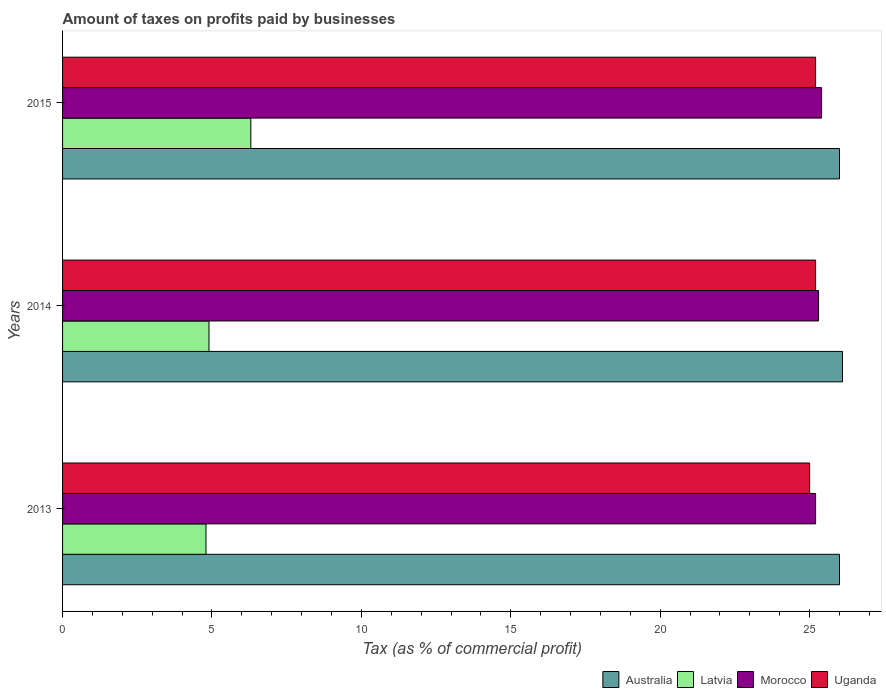How many different coloured bars are there?
Provide a succinct answer. 4. How many groups of bars are there?
Make the answer very short. 3. Are the number of bars per tick equal to the number of legend labels?
Your response must be concise. Yes. Are the number of bars on each tick of the Y-axis equal?
Offer a very short reply. Yes. How many bars are there on the 1st tick from the top?
Make the answer very short. 4. What is the label of the 1st group of bars from the top?
Make the answer very short. 2015. In how many cases, is the number of bars for a given year not equal to the number of legend labels?
Provide a succinct answer. 0. What is the percentage of taxes paid by businesses in Morocco in 2014?
Ensure brevity in your answer.  25.3. Across all years, what is the maximum percentage of taxes paid by businesses in Uganda?
Keep it short and to the point. 25.2. Across all years, what is the minimum percentage of taxes paid by businesses in Latvia?
Provide a short and direct response. 4.8. In which year was the percentage of taxes paid by businesses in Morocco maximum?
Offer a terse response. 2015. In which year was the percentage of taxes paid by businesses in Uganda minimum?
Keep it short and to the point. 2013. What is the difference between the percentage of taxes paid by businesses in Morocco in 2013 and that in 2014?
Provide a short and direct response. -0.1. What is the difference between the percentage of taxes paid by businesses in Australia in 2014 and the percentage of taxes paid by businesses in Uganda in 2015?
Your answer should be very brief. 0.9. What is the average percentage of taxes paid by businesses in Latvia per year?
Make the answer very short. 5.33. In the year 2015, what is the difference between the percentage of taxes paid by businesses in Australia and percentage of taxes paid by businesses in Morocco?
Offer a very short reply. 0.6. What is the ratio of the percentage of taxes paid by businesses in Morocco in 2013 to that in 2014?
Make the answer very short. 1. Is the percentage of taxes paid by businesses in Australia in 2013 less than that in 2014?
Offer a terse response. Yes. What is the difference between the highest and the second highest percentage of taxes paid by businesses in Australia?
Offer a very short reply. 0.1. Is the sum of the percentage of taxes paid by businesses in Morocco in 2013 and 2015 greater than the maximum percentage of taxes paid by businesses in Latvia across all years?
Keep it short and to the point. Yes. What does the 3rd bar from the bottom in 2015 represents?
Offer a terse response. Morocco. How many bars are there?
Ensure brevity in your answer.  12. Are all the bars in the graph horizontal?
Offer a very short reply. Yes. How many years are there in the graph?
Give a very brief answer. 3. What is the difference between two consecutive major ticks on the X-axis?
Your answer should be very brief. 5. How many legend labels are there?
Make the answer very short. 4. What is the title of the graph?
Your answer should be very brief. Amount of taxes on profits paid by businesses. Does "Marshall Islands" appear as one of the legend labels in the graph?
Offer a terse response. No. What is the label or title of the X-axis?
Provide a succinct answer. Tax (as % of commercial profit). What is the Tax (as % of commercial profit) in Australia in 2013?
Provide a succinct answer. 26. What is the Tax (as % of commercial profit) in Latvia in 2013?
Your answer should be very brief. 4.8. What is the Tax (as % of commercial profit) in Morocco in 2013?
Provide a succinct answer. 25.2. What is the Tax (as % of commercial profit) in Australia in 2014?
Provide a succinct answer. 26.1. What is the Tax (as % of commercial profit) in Latvia in 2014?
Your answer should be compact. 4.9. What is the Tax (as % of commercial profit) in Morocco in 2014?
Make the answer very short. 25.3. What is the Tax (as % of commercial profit) in Uganda in 2014?
Give a very brief answer. 25.2. What is the Tax (as % of commercial profit) in Australia in 2015?
Make the answer very short. 26. What is the Tax (as % of commercial profit) in Morocco in 2015?
Ensure brevity in your answer.  25.4. What is the Tax (as % of commercial profit) of Uganda in 2015?
Give a very brief answer. 25.2. Across all years, what is the maximum Tax (as % of commercial profit) in Australia?
Offer a terse response. 26.1. Across all years, what is the maximum Tax (as % of commercial profit) in Morocco?
Your answer should be compact. 25.4. Across all years, what is the maximum Tax (as % of commercial profit) in Uganda?
Provide a succinct answer. 25.2. Across all years, what is the minimum Tax (as % of commercial profit) of Morocco?
Keep it short and to the point. 25.2. Across all years, what is the minimum Tax (as % of commercial profit) in Uganda?
Provide a short and direct response. 25. What is the total Tax (as % of commercial profit) in Australia in the graph?
Your answer should be very brief. 78.1. What is the total Tax (as % of commercial profit) in Latvia in the graph?
Provide a short and direct response. 16. What is the total Tax (as % of commercial profit) of Morocco in the graph?
Ensure brevity in your answer.  75.9. What is the total Tax (as % of commercial profit) in Uganda in the graph?
Provide a succinct answer. 75.4. What is the difference between the Tax (as % of commercial profit) in Australia in 2013 and that in 2014?
Your answer should be very brief. -0.1. What is the difference between the Tax (as % of commercial profit) in Latvia in 2013 and that in 2014?
Ensure brevity in your answer.  -0.1. What is the difference between the Tax (as % of commercial profit) of Morocco in 2013 and that in 2014?
Give a very brief answer. -0.1. What is the difference between the Tax (as % of commercial profit) in Australia in 2013 and that in 2015?
Offer a terse response. 0. What is the difference between the Tax (as % of commercial profit) of Morocco in 2013 and that in 2015?
Keep it short and to the point. -0.2. What is the difference between the Tax (as % of commercial profit) in Latvia in 2014 and that in 2015?
Make the answer very short. -1.4. What is the difference between the Tax (as % of commercial profit) in Uganda in 2014 and that in 2015?
Your answer should be very brief. 0. What is the difference between the Tax (as % of commercial profit) in Australia in 2013 and the Tax (as % of commercial profit) in Latvia in 2014?
Ensure brevity in your answer.  21.1. What is the difference between the Tax (as % of commercial profit) in Latvia in 2013 and the Tax (as % of commercial profit) in Morocco in 2014?
Your answer should be very brief. -20.5. What is the difference between the Tax (as % of commercial profit) of Latvia in 2013 and the Tax (as % of commercial profit) of Uganda in 2014?
Offer a very short reply. -20.4. What is the difference between the Tax (as % of commercial profit) of Australia in 2013 and the Tax (as % of commercial profit) of Latvia in 2015?
Keep it short and to the point. 19.7. What is the difference between the Tax (as % of commercial profit) of Australia in 2013 and the Tax (as % of commercial profit) of Uganda in 2015?
Provide a short and direct response. 0.8. What is the difference between the Tax (as % of commercial profit) of Latvia in 2013 and the Tax (as % of commercial profit) of Morocco in 2015?
Ensure brevity in your answer.  -20.6. What is the difference between the Tax (as % of commercial profit) in Latvia in 2013 and the Tax (as % of commercial profit) in Uganda in 2015?
Offer a very short reply. -20.4. What is the difference between the Tax (as % of commercial profit) of Australia in 2014 and the Tax (as % of commercial profit) of Latvia in 2015?
Offer a very short reply. 19.8. What is the difference between the Tax (as % of commercial profit) in Latvia in 2014 and the Tax (as % of commercial profit) in Morocco in 2015?
Ensure brevity in your answer.  -20.5. What is the difference between the Tax (as % of commercial profit) in Latvia in 2014 and the Tax (as % of commercial profit) in Uganda in 2015?
Your answer should be compact. -20.3. What is the average Tax (as % of commercial profit) in Australia per year?
Offer a very short reply. 26.03. What is the average Tax (as % of commercial profit) in Latvia per year?
Give a very brief answer. 5.33. What is the average Tax (as % of commercial profit) in Morocco per year?
Your response must be concise. 25.3. What is the average Tax (as % of commercial profit) in Uganda per year?
Give a very brief answer. 25.13. In the year 2013, what is the difference between the Tax (as % of commercial profit) in Australia and Tax (as % of commercial profit) in Latvia?
Make the answer very short. 21.2. In the year 2013, what is the difference between the Tax (as % of commercial profit) of Latvia and Tax (as % of commercial profit) of Morocco?
Give a very brief answer. -20.4. In the year 2013, what is the difference between the Tax (as % of commercial profit) of Latvia and Tax (as % of commercial profit) of Uganda?
Ensure brevity in your answer.  -20.2. In the year 2013, what is the difference between the Tax (as % of commercial profit) in Morocco and Tax (as % of commercial profit) in Uganda?
Your response must be concise. 0.2. In the year 2014, what is the difference between the Tax (as % of commercial profit) in Australia and Tax (as % of commercial profit) in Latvia?
Keep it short and to the point. 21.2. In the year 2014, what is the difference between the Tax (as % of commercial profit) in Latvia and Tax (as % of commercial profit) in Morocco?
Offer a very short reply. -20.4. In the year 2014, what is the difference between the Tax (as % of commercial profit) of Latvia and Tax (as % of commercial profit) of Uganda?
Your answer should be very brief. -20.3. In the year 2014, what is the difference between the Tax (as % of commercial profit) in Morocco and Tax (as % of commercial profit) in Uganda?
Provide a succinct answer. 0.1. In the year 2015, what is the difference between the Tax (as % of commercial profit) of Latvia and Tax (as % of commercial profit) of Morocco?
Provide a succinct answer. -19.1. In the year 2015, what is the difference between the Tax (as % of commercial profit) of Latvia and Tax (as % of commercial profit) of Uganda?
Make the answer very short. -18.9. What is the ratio of the Tax (as % of commercial profit) of Latvia in 2013 to that in 2014?
Provide a succinct answer. 0.98. What is the ratio of the Tax (as % of commercial profit) in Uganda in 2013 to that in 2014?
Your answer should be very brief. 0.99. What is the ratio of the Tax (as % of commercial profit) in Latvia in 2013 to that in 2015?
Provide a succinct answer. 0.76. What is the ratio of the Tax (as % of commercial profit) of Uganda in 2013 to that in 2015?
Keep it short and to the point. 0.99. What is the ratio of the Tax (as % of commercial profit) of Australia in 2014 to that in 2015?
Ensure brevity in your answer.  1. What is the ratio of the Tax (as % of commercial profit) of Latvia in 2014 to that in 2015?
Make the answer very short. 0.78. What is the difference between the highest and the second highest Tax (as % of commercial profit) of Australia?
Keep it short and to the point. 0.1. What is the difference between the highest and the second highest Tax (as % of commercial profit) in Uganda?
Your response must be concise. 0. What is the difference between the highest and the lowest Tax (as % of commercial profit) in Latvia?
Ensure brevity in your answer.  1.5. What is the difference between the highest and the lowest Tax (as % of commercial profit) of Uganda?
Offer a very short reply. 0.2. 